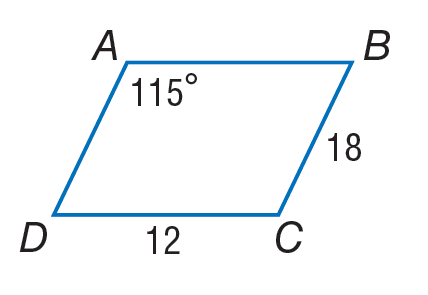Answer the mathemtical geometry problem and directly provide the correct option letter.
Question: Use parallelogram A B C D to find the measure of m \angle A D C.
Choices: A: 21 B: 65 C: 105 D: 115 B 